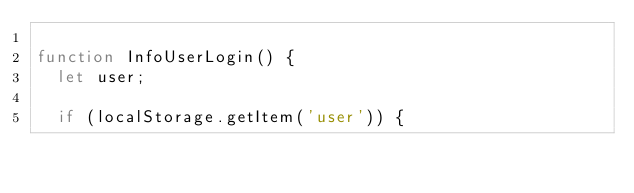Convert code to text. <code><loc_0><loc_0><loc_500><loc_500><_JavaScript_>
function InfoUserLogin() {
  let user;

  if (localStorage.getItem('user')) {</code> 